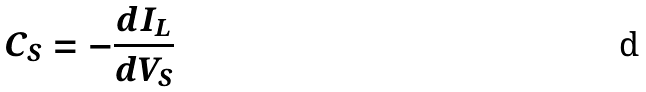Convert formula to latex. <formula><loc_0><loc_0><loc_500><loc_500>C _ { S } = - \frac { d I _ { L } } { d V _ { S } }</formula> 